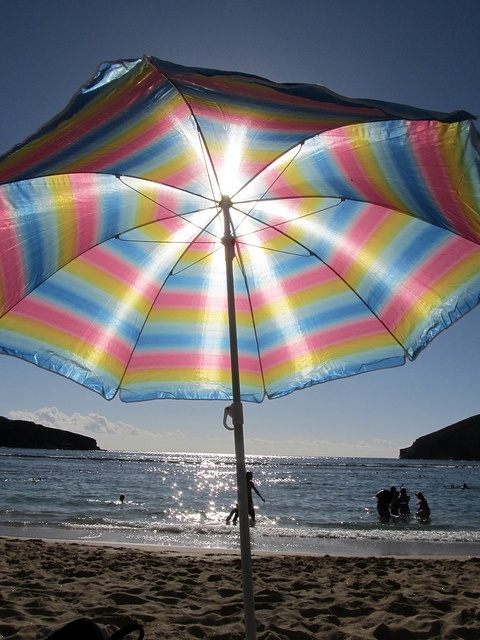Describe the objects in this image and their specific colors. I can see umbrella in navy, white, gray, darkgray, and olive tones, people in navy, black, gray, and darkgray tones, people in navy, black, gray, and darkblue tones, people in navy, black, gray, and blue tones, and people in navy, black, gray, and purple tones in this image. 